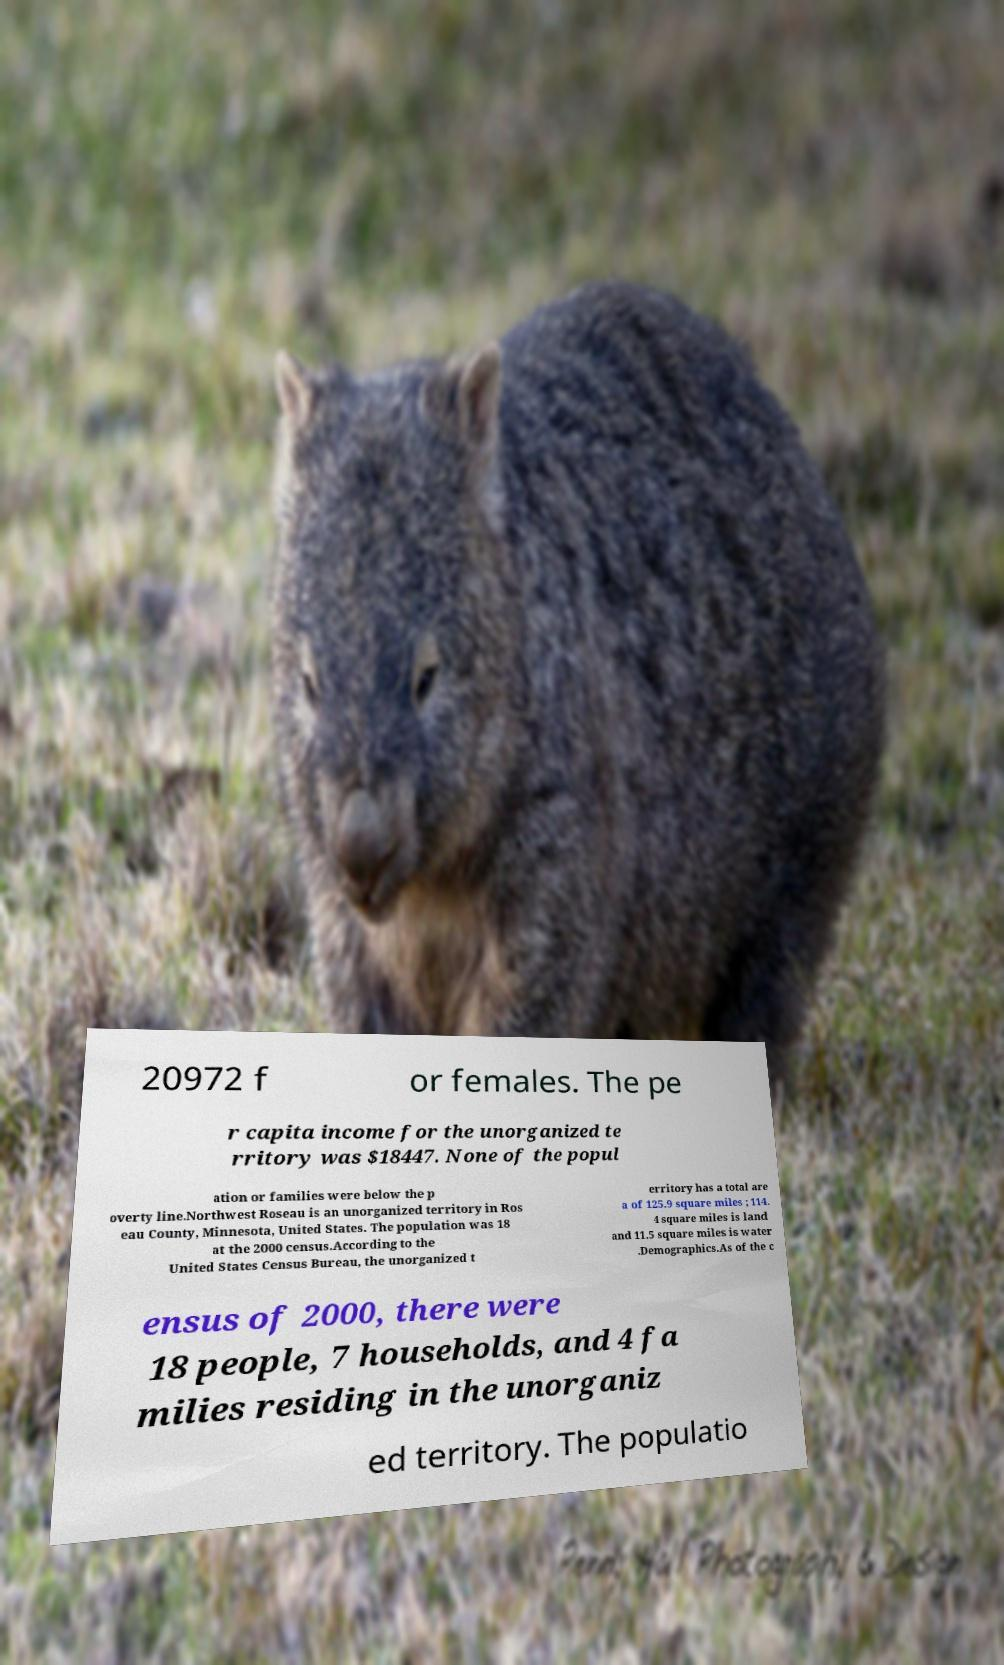Please read and relay the text visible in this image. What does it say? 20972 f or females. The pe r capita income for the unorganized te rritory was $18447. None of the popul ation or families were below the p overty line.Northwest Roseau is an unorganized territory in Ros eau County, Minnesota, United States. The population was 18 at the 2000 census.According to the United States Census Bureau, the unorganized t erritory has a total are a of 125.9 square miles ; 114. 4 square miles is land and 11.5 square miles is water .Demographics.As of the c ensus of 2000, there were 18 people, 7 households, and 4 fa milies residing in the unorganiz ed territory. The populatio 